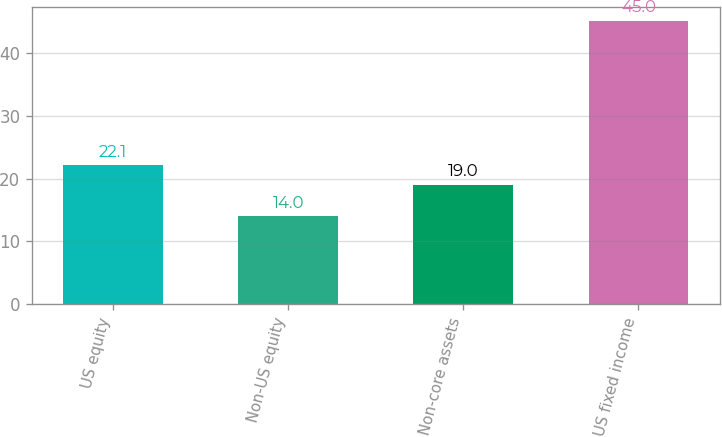Convert chart to OTSL. <chart><loc_0><loc_0><loc_500><loc_500><bar_chart><fcel>US equity<fcel>Non-US equity<fcel>Non-core assets<fcel>US fixed income<nl><fcel>22.1<fcel>14<fcel>19<fcel>45<nl></chart> 